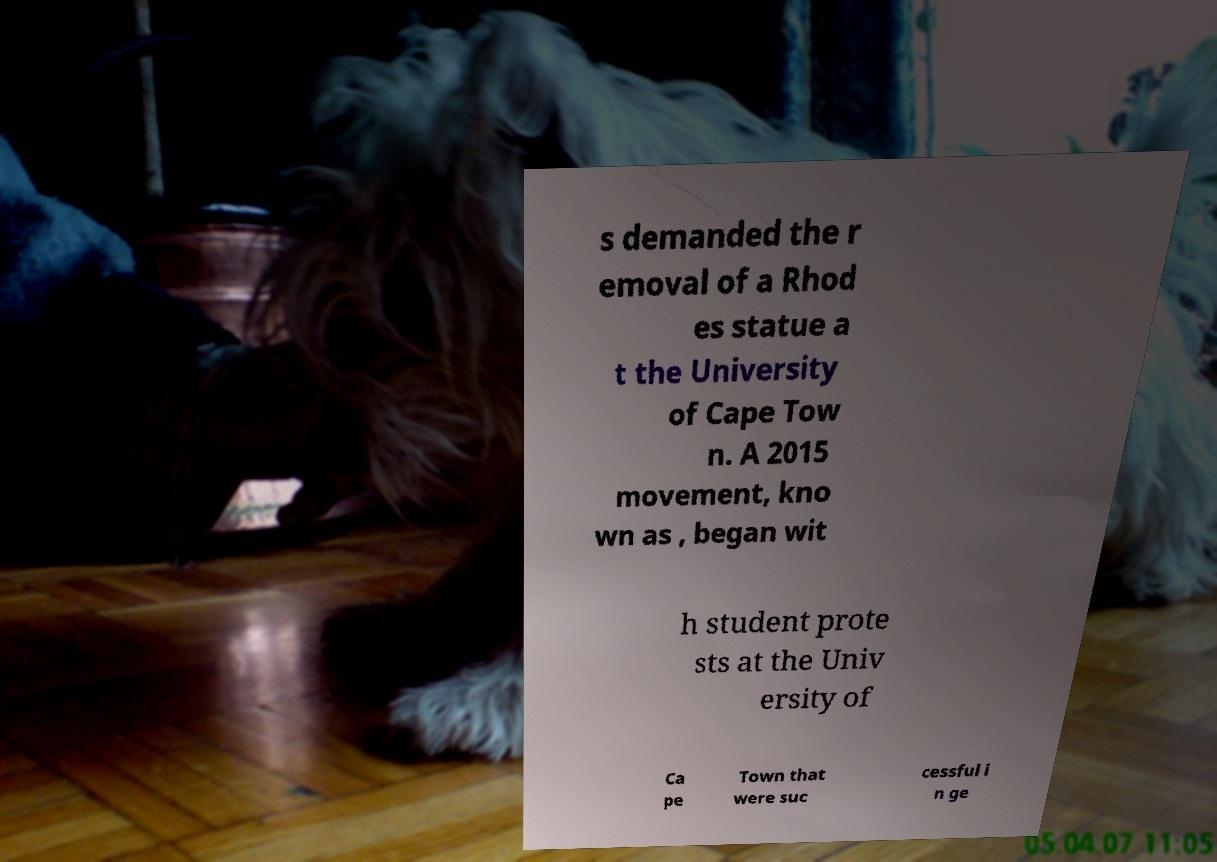Please identify and transcribe the text found in this image. s demanded the r emoval of a Rhod es statue a t the University of Cape Tow n. A 2015 movement, kno wn as , began wit h student prote sts at the Univ ersity of Ca pe Town that were suc cessful i n ge 